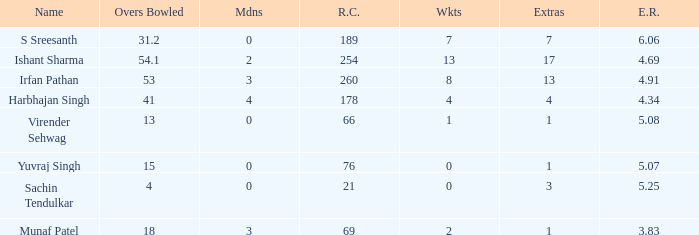Can you parse all the data within this table? {'header': ['Name', 'Overs Bowled', 'Mdns', 'R.C.', 'Wkts', 'Extras', 'E.R.'], 'rows': [['S Sreesanth', '31.2', '0', '189', '7', '7', '6.06'], ['Ishant Sharma', '54.1', '2', '254', '13', '17', '4.69'], ['Irfan Pathan', '53', '3', '260', '8', '13', '4.91'], ['Harbhajan Singh', '41', '4', '178', '4', '4', '4.34'], ['Virender Sehwag', '13', '0', '66', '1', '1', '5.08'], ['Yuvraj Singh', '15', '0', '76', '0', '1', '5.07'], ['Sachin Tendulkar', '4', '0', '21', '0', '3', '5.25'], ['Munaf Patel', '18', '3', '69', '2', '1', '3.83']]} Name the name for when overs bowled is 31.2 S Sreesanth. 